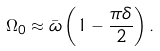<formula> <loc_0><loc_0><loc_500><loc_500>\Omega _ { 0 } \approx \bar { \omega } \left ( 1 - \frac { \pi \delta } { 2 } \right ) .</formula> 